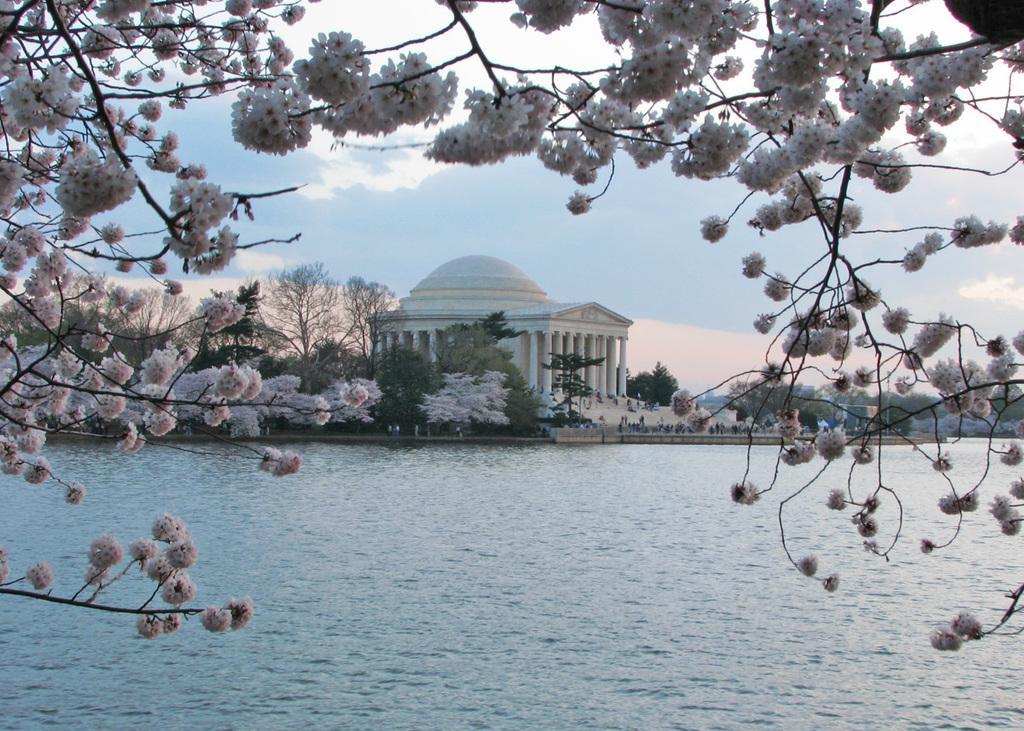Could you give a brief overview of what you see in this image? This image is taken outdoors. At the bottom of the image there is a pond with water. At the top of the image there is a sky with clouds. In the middle of the image there is a building with walls, pillars, a door and a roof. There are many trees and plants on the ground. On the left and right sides of the image there is a tree with beautiful white flowers. 